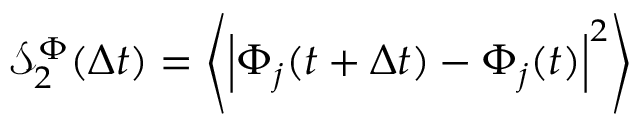<formula> <loc_0><loc_0><loc_500><loc_500>\mathcal { S } _ { 2 } ^ { \Phi } ( \Delta t ) = \left \langle \left | \Phi _ { j } ( t + \Delta t ) - \Phi _ { j } ( t ) \right | ^ { 2 } \right \rangle</formula> 